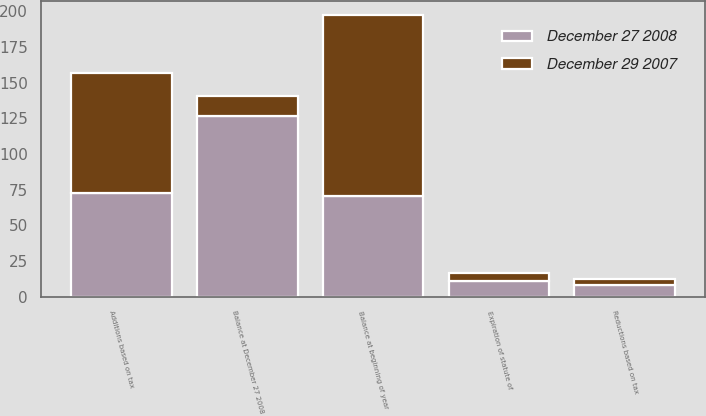Convert chart. <chart><loc_0><loc_0><loc_500><loc_500><stacked_bar_chart><ecel><fcel>Balance at beginning of year<fcel>Additions based on tax<fcel>Reductions based on tax<fcel>Expiration of statute of<fcel>Balance at December 27 2008<nl><fcel>December 29 2007<fcel>126.6<fcel>83.8<fcel>4.6<fcel>5.6<fcel>14.2<nl><fcel>December 27 2008<fcel>70.5<fcel>73<fcel>8<fcel>11.3<fcel>126.6<nl></chart> 